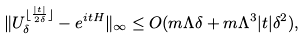Convert formula to latex. <formula><loc_0><loc_0><loc_500><loc_500>\| U _ { \delta } ^ { \lfloor \frac { | t | } { 2 \delta } \rfloor } - e ^ { i t H } \| _ { \infty } \leq O ( m \Lambda \delta + m \Lambda ^ { 3 } | t | \delta ^ { 2 } ) ,</formula> 